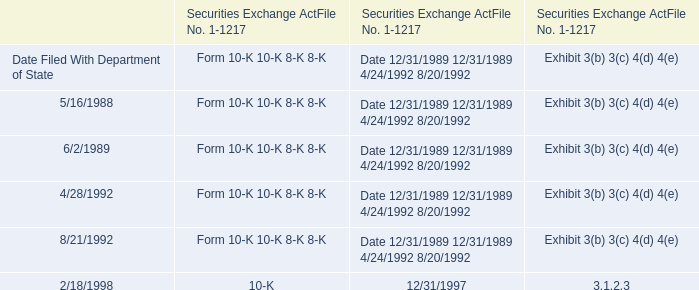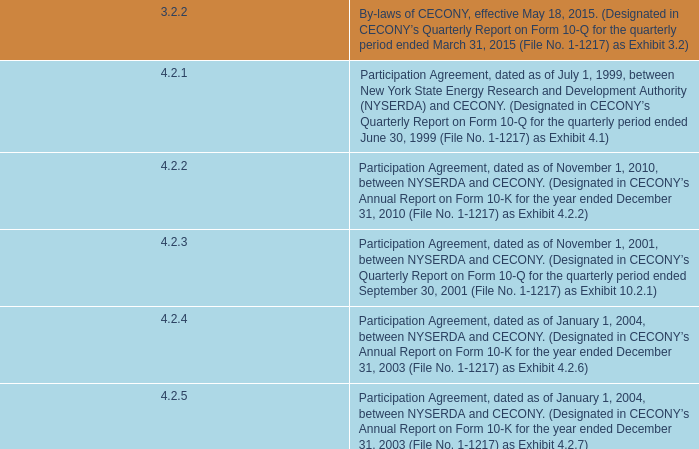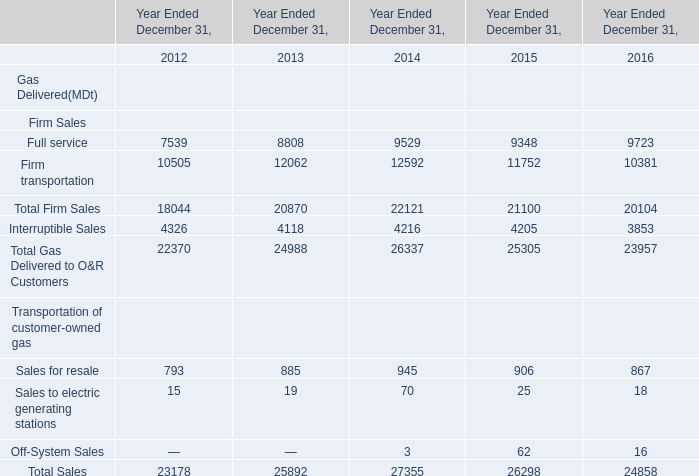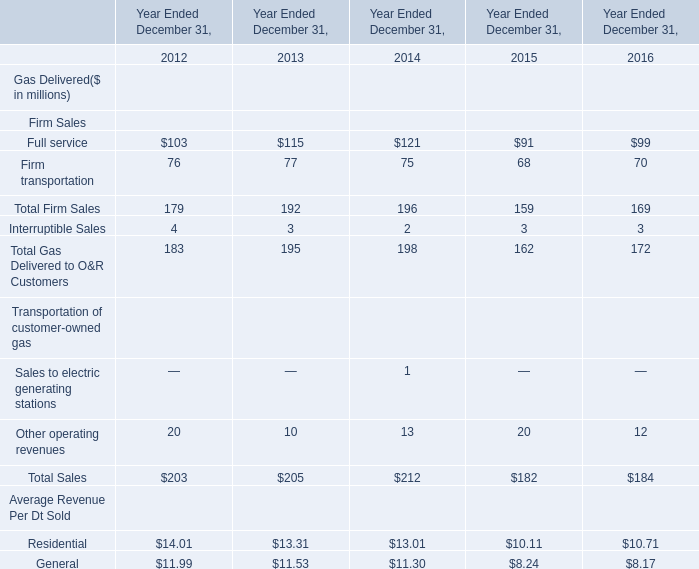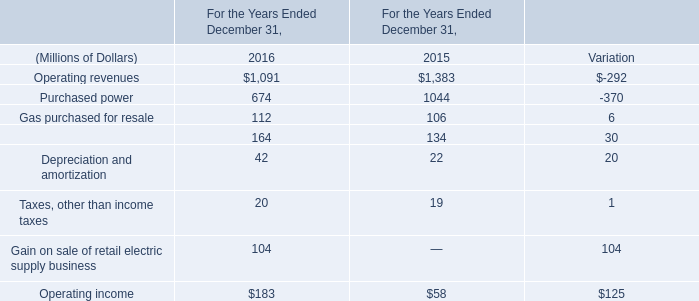If Total Sales develops with the same increasing rate in 2016, what will it reach in 2017? (in dollars in millions) 
Computations: (184 * (1 + ((184 - 182) / 182)))
Answer: 186.02198. 